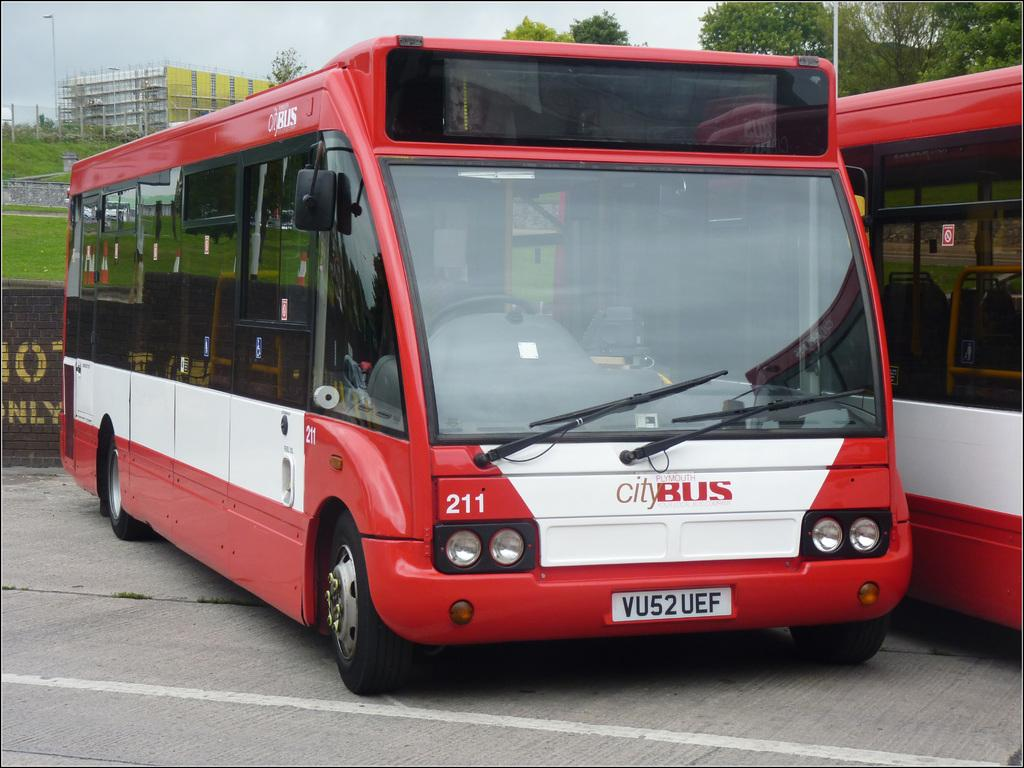What type of vehicles are in the middle of the image? There are two buses in the middle of the image. What can be seen in the background of the image? There are trees in the background of the image. What structure is located on the left side of the image? There is a building on the left side of the image. What is visible at the top of the image? The sky is visible at the top of the image. Where is the dirt pile located in the image? There is no dirt pile present in the image. What type of school can be seen in the image? There is no school present in the image; it features two buses, trees, a building, and the sky. 